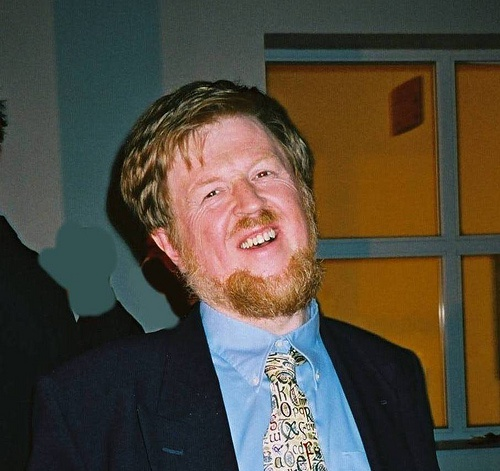Describe the objects in this image and their specific colors. I can see people in black, lightpink, lightblue, and maroon tones and tie in black, lightgray, darkgray, and gray tones in this image. 